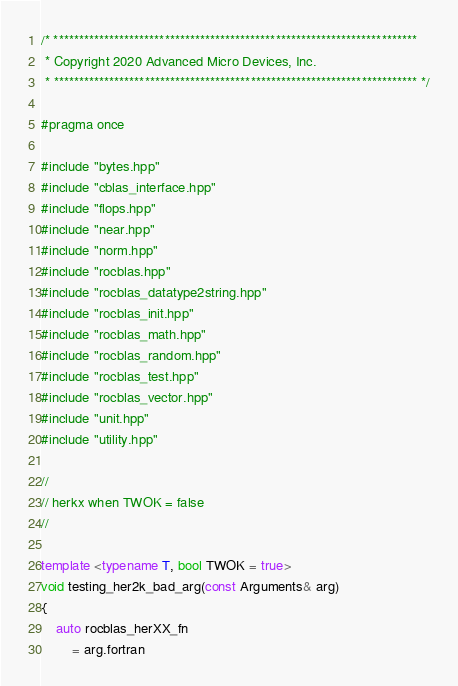<code> <loc_0><loc_0><loc_500><loc_500><_C++_>/* ************************************************************************
 * Copyright 2020 Advanced Micro Devices, Inc.
 * ************************************************************************ */

#pragma once

#include "bytes.hpp"
#include "cblas_interface.hpp"
#include "flops.hpp"
#include "near.hpp"
#include "norm.hpp"
#include "rocblas.hpp"
#include "rocblas_datatype2string.hpp"
#include "rocblas_init.hpp"
#include "rocblas_math.hpp"
#include "rocblas_random.hpp"
#include "rocblas_test.hpp"
#include "rocblas_vector.hpp"
#include "unit.hpp"
#include "utility.hpp"

//
// herkx when TWOK = false
//

template <typename T, bool TWOK = true>
void testing_her2k_bad_arg(const Arguments& arg)
{
    auto rocblas_herXX_fn
        = arg.fortran</code> 